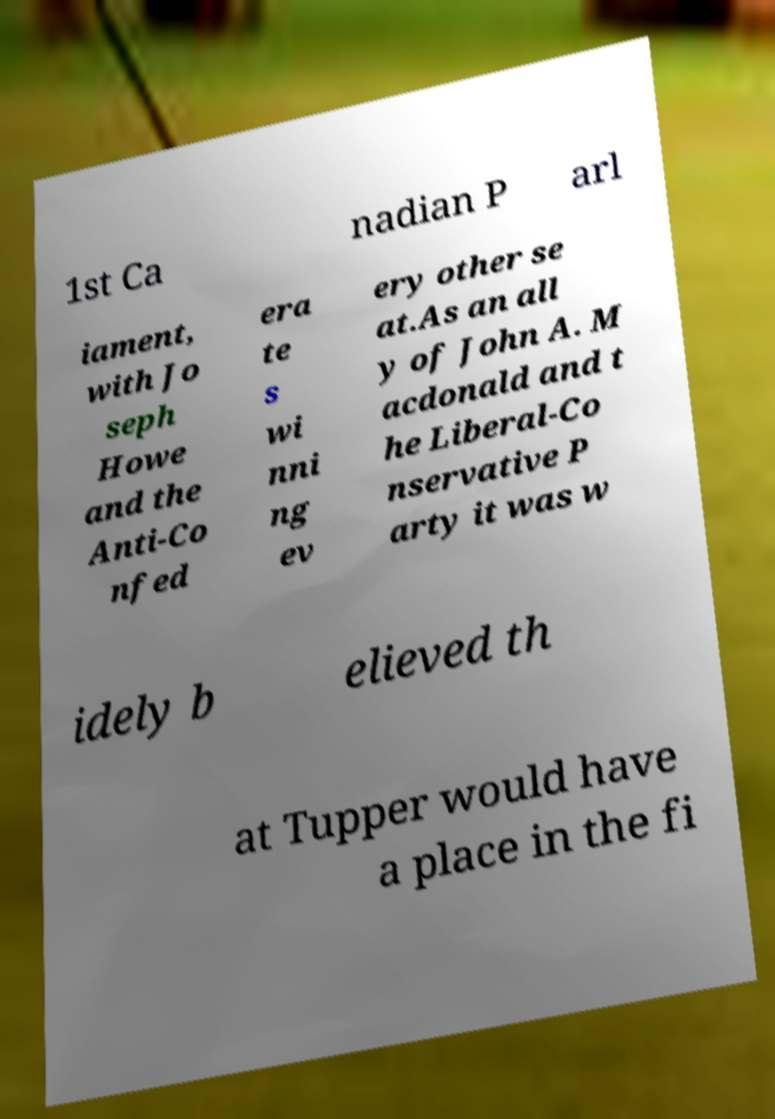Can you accurately transcribe the text from the provided image for me? 1st Ca nadian P arl iament, with Jo seph Howe and the Anti-Co nfed era te s wi nni ng ev ery other se at.As an all y of John A. M acdonald and t he Liberal-Co nservative P arty it was w idely b elieved th at Tupper would have a place in the fi 